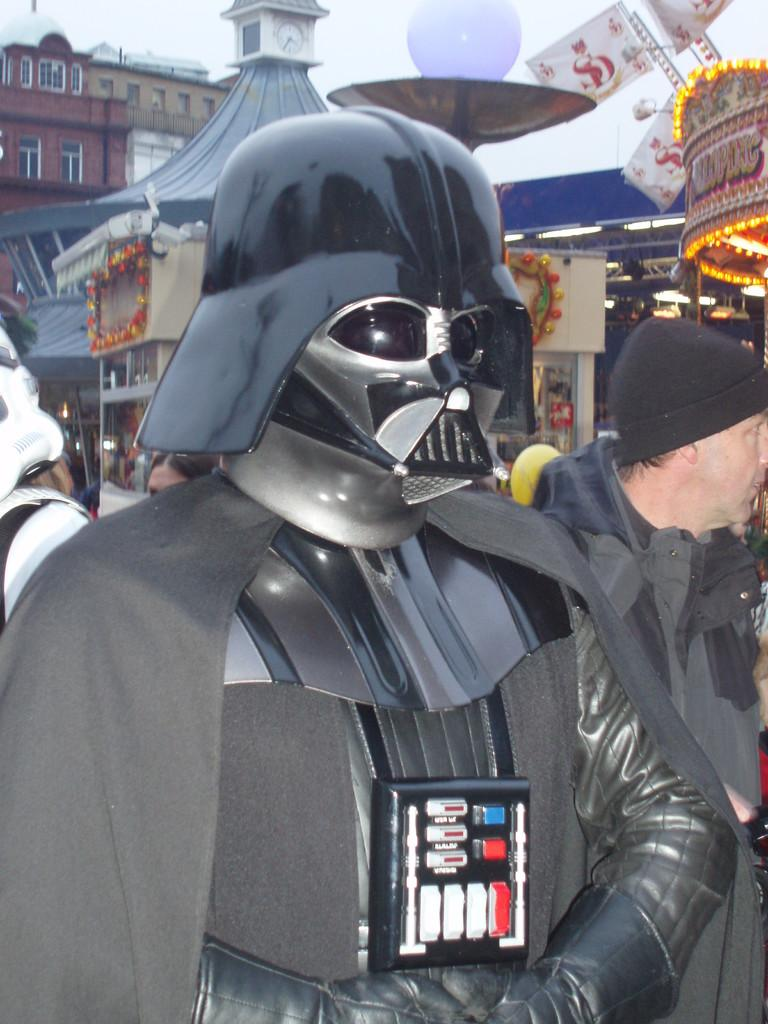What is the person in the image wearing? The person in the image is wearing a fancy dress. Can you describe the surroundings of the person in the image? There are people and buildings in the background of the image. What is the argument about between the person and the elbow in the image? There is no argument or elbow present in the image. 